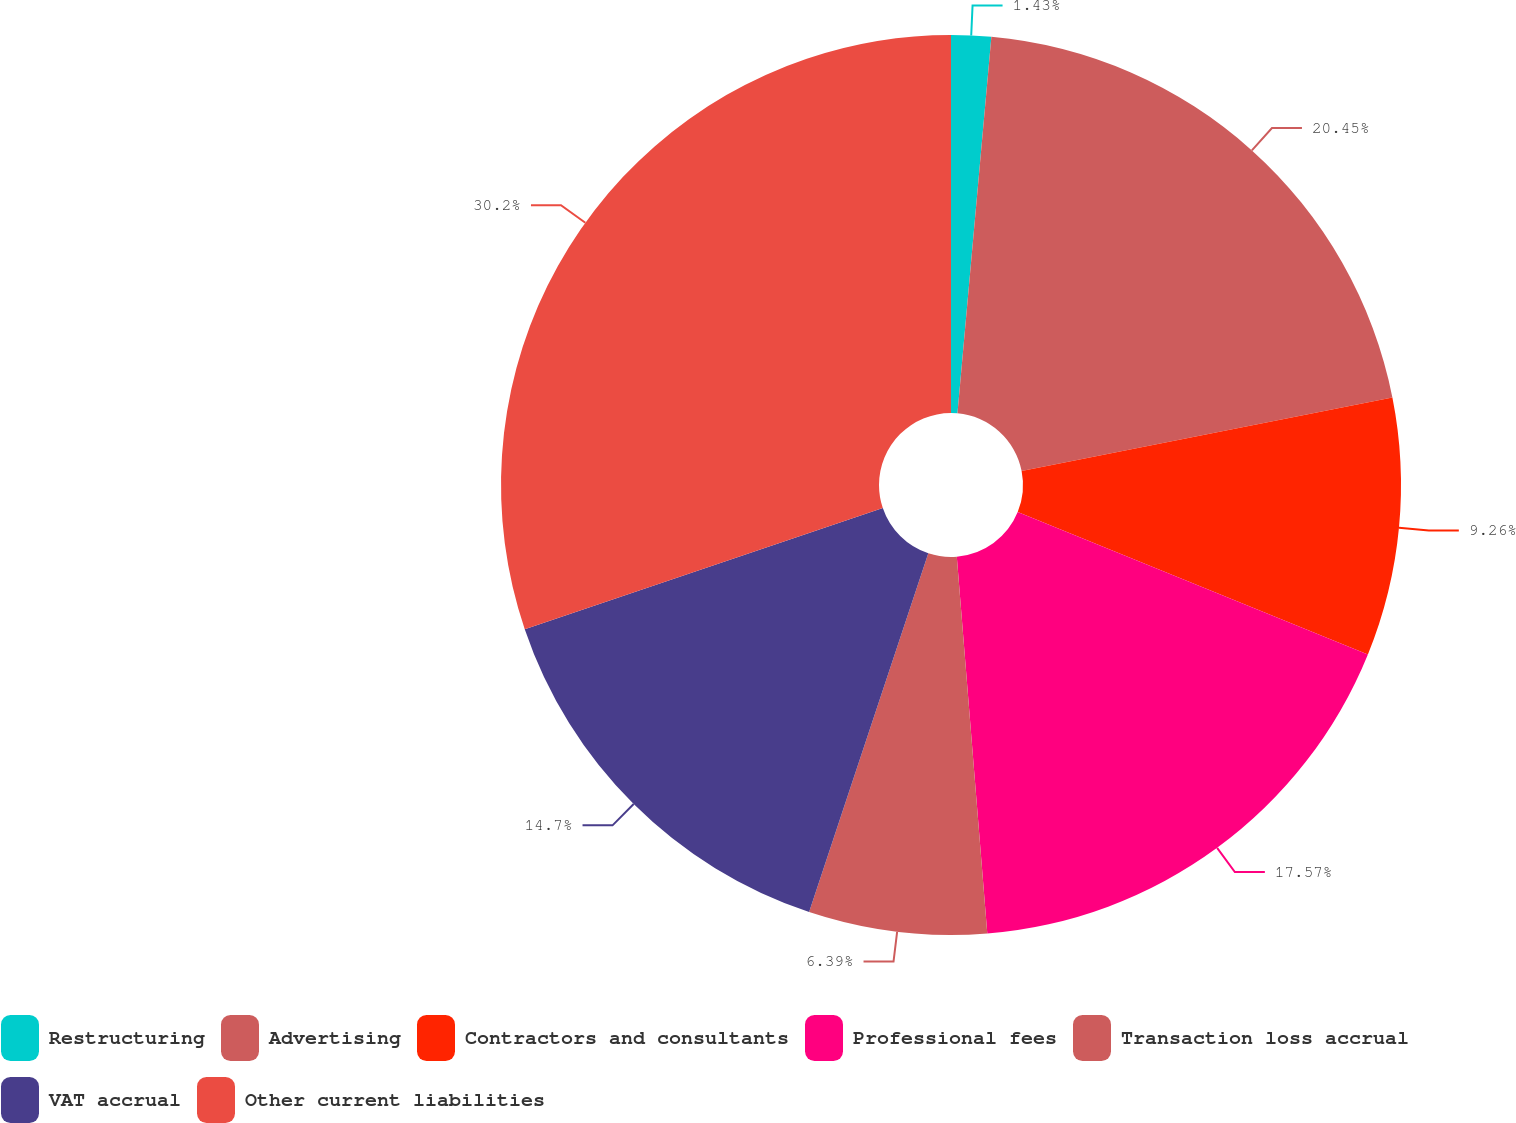<chart> <loc_0><loc_0><loc_500><loc_500><pie_chart><fcel>Restructuring<fcel>Advertising<fcel>Contractors and consultants<fcel>Professional fees<fcel>Transaction loss accrual<fcel>VAT accrual<fcel>Other current liabilities<nl><fcel>1.43%<fcel>20.45%<fcel>9.26%<fcel>17.57%<fcel>6.39%<fcel>14.7%<fcel>30.19%<nl></chart> 